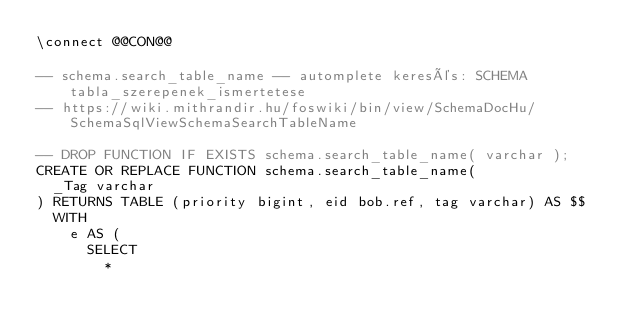<code> <loc_0><loc_0><loc_500><loc_500><_SQL_>\connect @@CON@@

-- schema.search_table_name -- automplete keresés: SCHEMA tabla_szerepenek_ismertetese
-- https://wiki.mithrandir.hu/foswiki/bin/view/SchemaDocHu/SchemaSqlViewSchemaSearchTableName

-- DROP FUNCTION IF EXISTS schema.search_table_name( varchar );
CREATE OR REPLACE FUNCTION schema.search_table_name(
  _Tag varchar
) RETURNS TABLE (priority bigint, eid bob.ref, tag varchar) AS $$
	WITH
		e AS (
			SELECT
				*</code> 